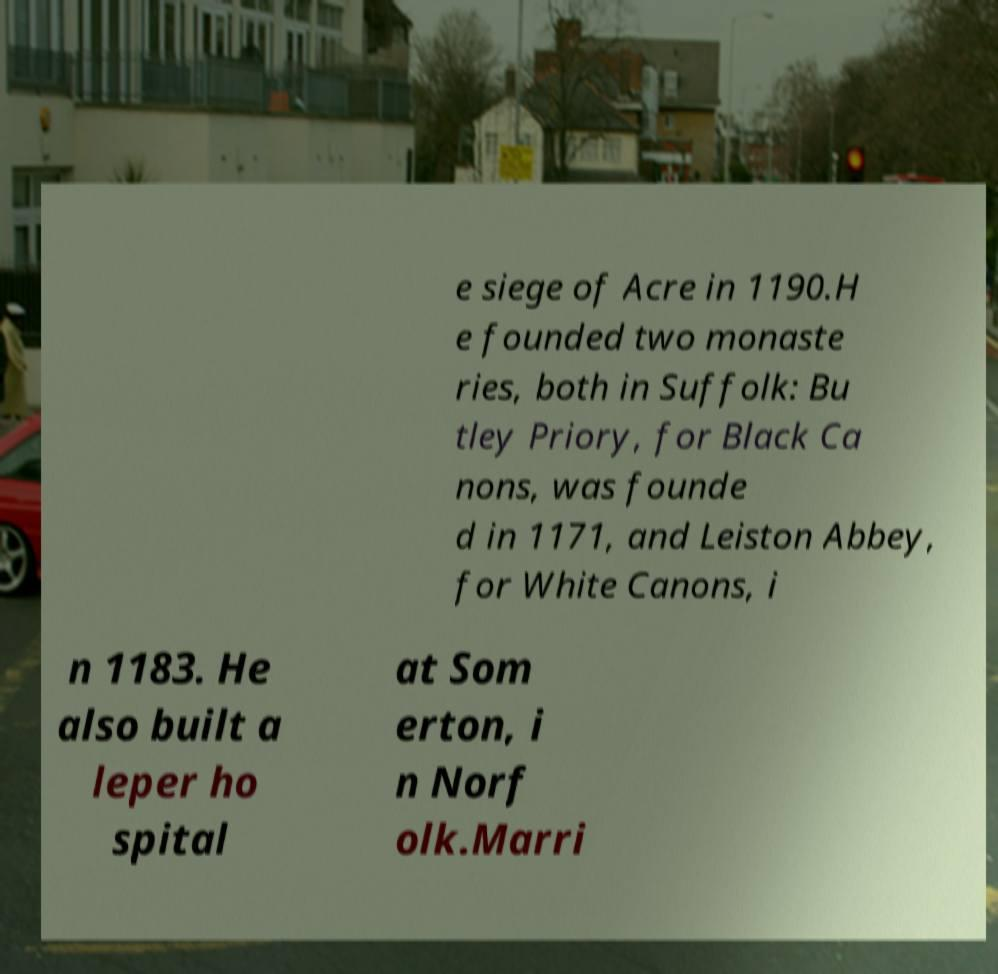Can you accurately transcribe the text from the provided image for me? e siege of Acre in 1190.H e founded two monaste ries, both in Suffolk: Bu tley Priory, for Black Ca nons, was founde d in 1171, and Leiston Abbey, for White Canons, i n 1183. He also built a leper ho spital at Som erton, i n Norf olk.Marri 